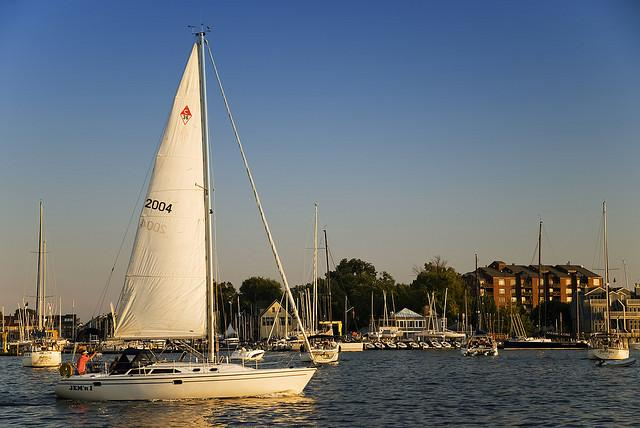What material is the sail mast made of? Please explain your reasoning. aluminum. The sail looks like it's sturdy without pulling the boat down. 